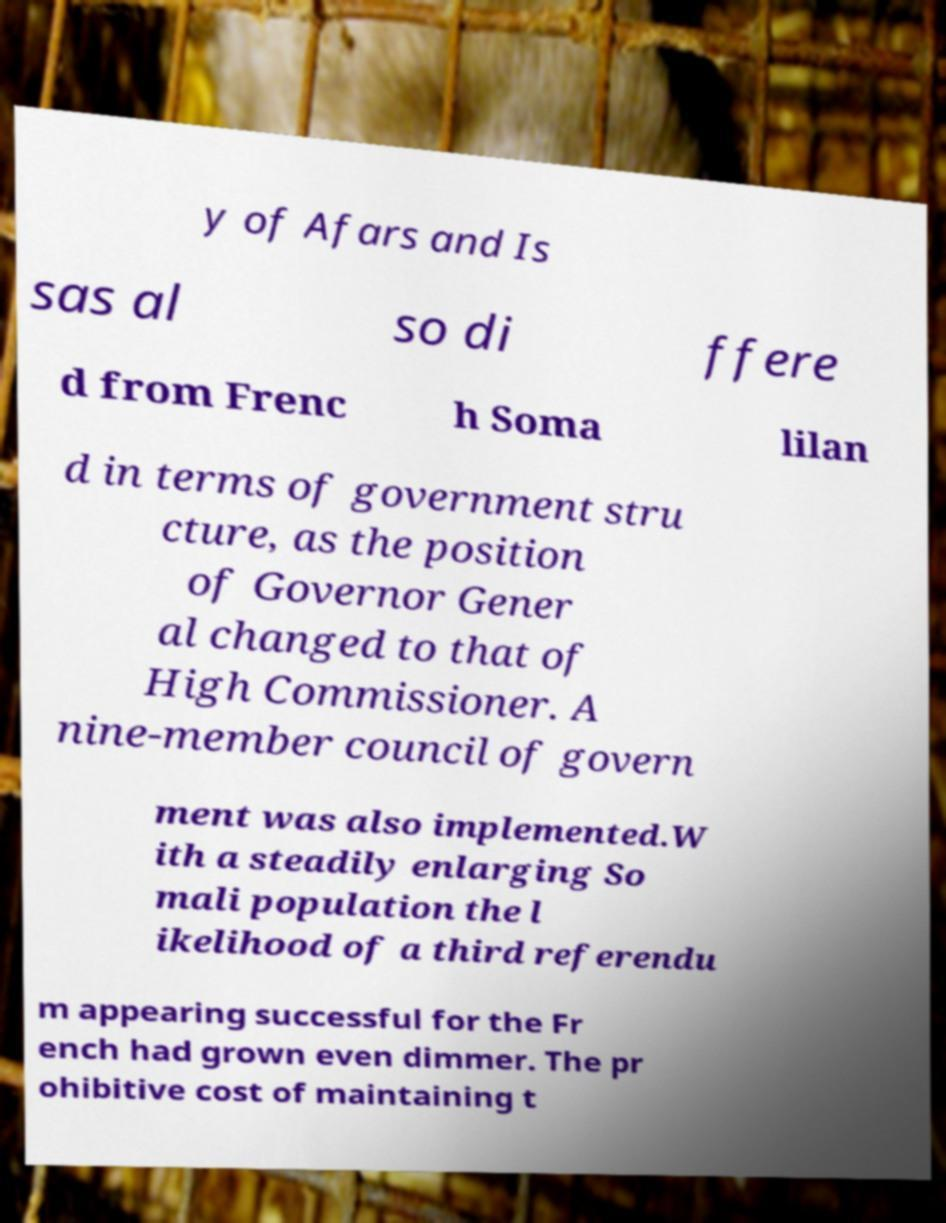Could you extract and type out the text from this image? y of Afars and Is sas al so di ffere d from Frenc h Soma lilan d in terms of government stru cture, as the position of Governor Gener al changed to that of High Commissioner. A nine-member council of govern ment was also implemented.W ith a steadily enlarging So mali population the l ikelihood of a third referendu m appearing successful for the Fr ench had grown even dimmer. The pr ohibitive cost of maintaining t 